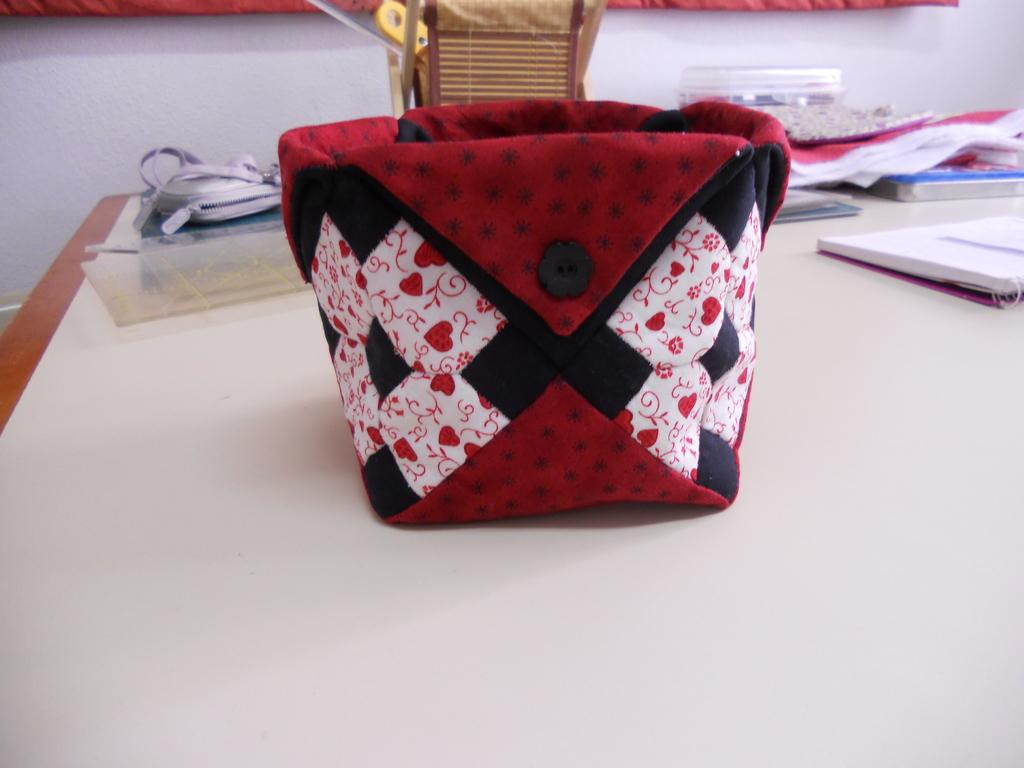What is on the table in the image? There is a bag on the table in the image. Where is the table located in the image? The table is in the center of the image. What can be seen behind the table in the image? There is a wall in the background of the image. What else is visible in the background of the image? There are objects in the background of the image. How many fingers can be seen in the image? There are no fingers visible in the image. Are there any brothers present in the image? There is no mention of brothers or any people in the image. 